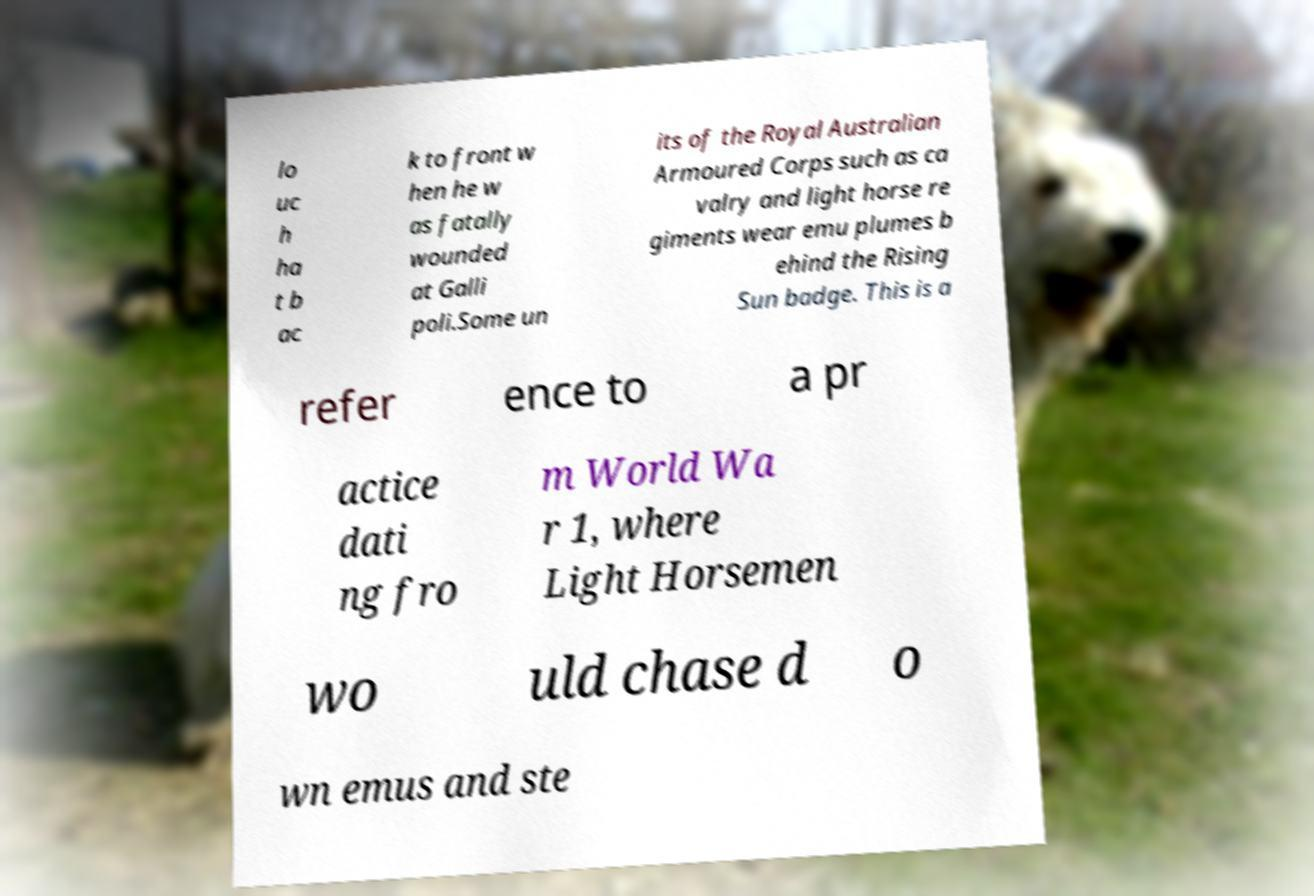Can you read and provide the text displayed in the image?This photo seems to have some interesting text. Can you extract and type it out for me? lo uc h ha t b ac k to front w hen he w as fatally wounded at Galli poli.Some un its of the Royal Australian Armoured Corps such as ca valry and light horse re giments wear emu plumes b ehind the Rising Sun badge. This is a refer ence to a pr actice dati ng fro m World Wa r 1, where Light Horsemen wo uld chase d o wn emus and ste 